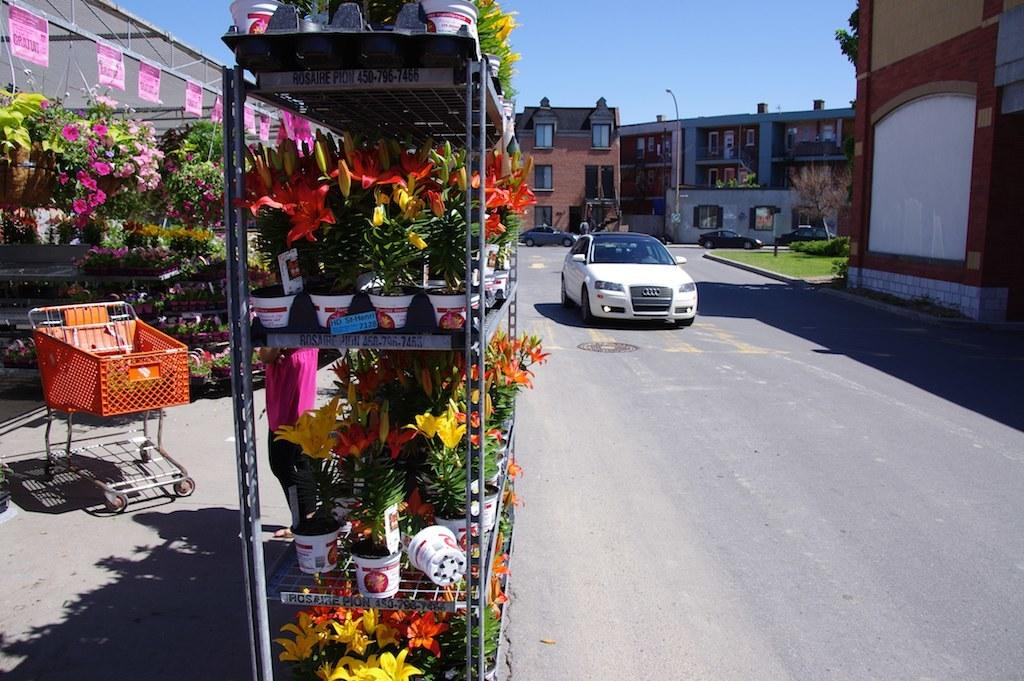What type of store is visible in the image? There is a florist store in the image. What can be seen on the road in the image? Cars are parked on the road in the image. What is visible in the background of the image? There are buildings visible in the background of the image. What type of wine is being served by the band in the image? There is no wine or band present in the image; it features a florist store and parked cars on the road. How many family members are visible in the image? There are no family members visible in the image; it only shows a florist store, parked cars, and buildings in the background. 